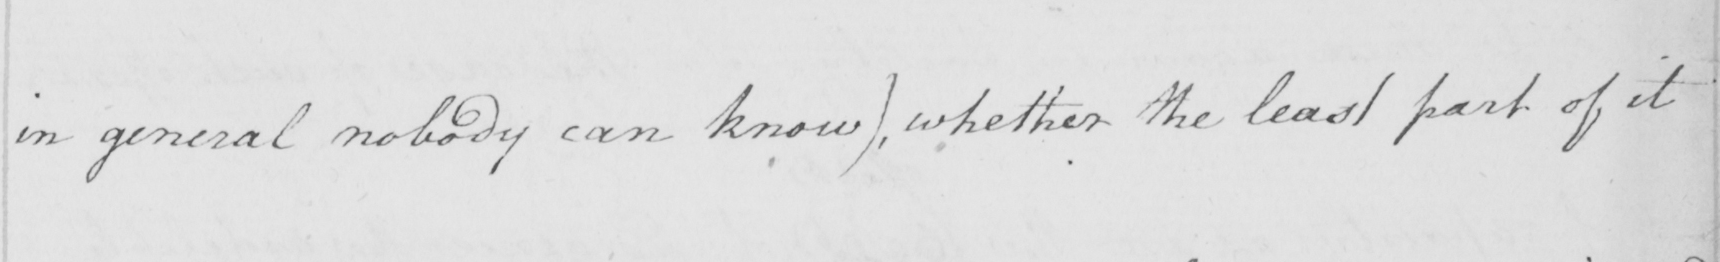What does this handwritten line say? in general nobody can know )  , whether the least part of it 